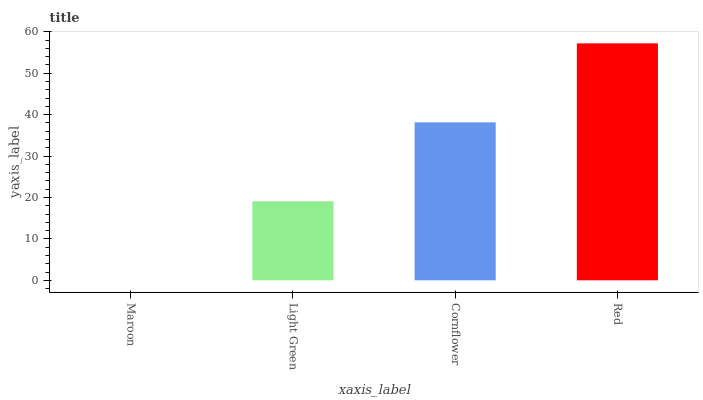Is Maroon the minimum?
Answer yes or no. Yes. Is Red the maximum?
Answer yes or no. Yes. Is Light Green the minimum?
Answer yes or no. No. Is Light Green the maximum?
Answer yes or no. No. Is Light Green greater than Maroon?
Answer yes or no. Yes. Is Maroon less than Light Green?
Answer yes or no. Yes. Is Maroon greater than Light Green?
Answer yes or no. No. Is Light Green less than Maroon?
Answer yes or no. No. Is Cornflower the high median?
Answer yes or no. Yes. Is Light Green the low median?
Answer yes or no. Yes. Is Maroon the high median?
Answer yes or no. No. Is Cornflower the low median?
Answer yes or no. No. 